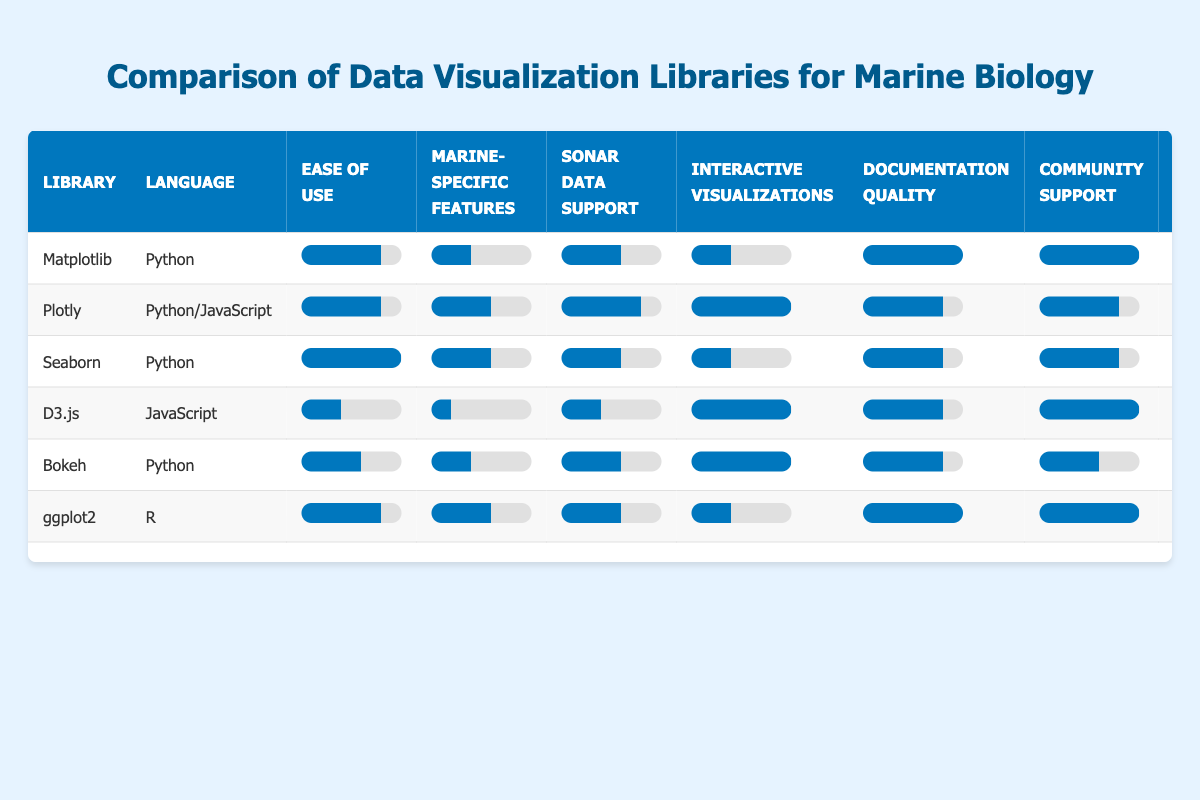What is the highest ease of use rating among the libraries? The ease of use ratings are as follows: Matplotlib (4), Plotly (4), Seaborn (5), D3.js (2), Bokeh (3), ggplot2 (4). The highest rating is 5, which belongs to Seaborn.
Answer: 5 Which library has the best documentation quality? The documentation quality ratings are: Matplotlib (5), Plotly (4), Seaborn (4), D3.js (4), Bokeh (4), and ggplot2 (5). The best documentation quality is shared by Matplotlib and ggplot2, both rated 5.
Answer: Matplotlib and ggplot2 How many libraries support 3D plotting? The libraries that support 3D plotting are Matplotlib, Plotly, D3.js, Bokeh, and ggplot2. In total, 5 libraries support 3D plotting.
Answer: 5 What is the average sonar data support rating of the libraries? The sonar data support ratings are: Matplotlib (3), Plotly (4), Seaborn (3), D3.js (2), Bokeh (3), and ggplot2 (3). To calculate the average: (3 + 4 + 3 + 2 + 3 + 3) = 18; then divide by 6, which gives 18/6 = 3.
Answer: 3 Does Plotly provide support for geospatial visualization? Plotly’s support for geospatial visualization is indicated as true in the table. Thus, it does provide support for this feature.
Answer: Yes Which library features the highest performance rating and what is that rating? The performance ratings are: Matplotlib (3), Plotly (4), Seaborn (3), D3.js (5), Bokeh (4), and ggplot2 (3). The highest performance rating is 5, which belongs to D3.js.
Answer: 5 (D3.js) How does the ease of use of Bokeh compare to that of ggplot2? Bokeh has an ease of use rating of 3, while ggplot2 has a rating of 4. Therefore, ggplot2 is easier to use compared to Bokeh.
Answer: Bokeh is less easy to use than ggplot2 Which library has the lowest community support rating, and what is that rating? The community support ratings are: Matplotlib (5), Plotly (4), Seaborn (4), D3.js (5), Bokeh (3), and ggplot2 (5). Bokeh has the lowest community support rating of 3.
Answer: Bokeh, rating 3 How many libraries have an ease of use rating below 4? The libraries with an ease of use rating below 4 are D3.js (2) and Bokeh (3), totaling two libraries.
Answer: 2 